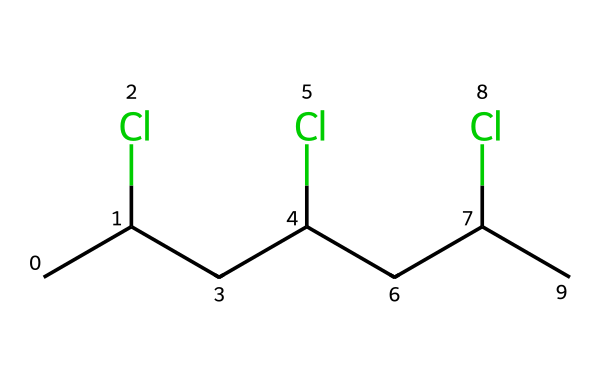What is the main polymer represented in this structure? The SMILES representation shows a recurring unit with chlorine (Cl) atoms attached to a carbon chain, indicating it is polyvinyl chloride (PVC).
Answer: polyvinyl chloride How many chlorine atoms are present in the structure? By analyzing the SMILES string, "CC(Cl)CC(Cl)CC(Cl)C," we see that there are three occurrences of "(Cl)," indicating three chlorine atoms.
Answer: 3 What type of bonds are primarily present in this polymer structure? The chemical primarily contains single covalent bonds connecting the carbon atoms and chlorine atoms in the polymer backbone. Polyvinyl chloride is known for these single bonds.
Answer: single covalent bonds What is the total number of carbon atoms in the polymer chain? The SMILES representation has "CC(Cl)CC(Cl)CC(Cl)C," which translates to a total of 6 carbon atoms when counted.
Answer: 6 What characteristic feature of polyvinyl chloride influences its insulation properties? The presence of chlorine atoms in the polymer backbone increases polarity and makes PVC a good electrical insulator due to reduced electrical conductivity.
Answer: chlorine atoms How would the presence of chlorine in this polymer affect its thermal stability? Chlorine increases the thermal stability of polyvinyl chloride by enabling better resistance to degradation at elevated temperatures compared to non-chlorinated polymers.
Answer: increases stability 